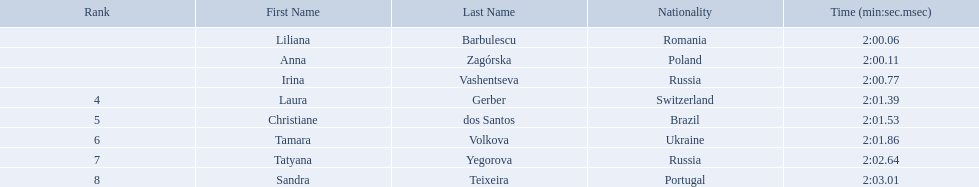What athletes are in the top five for the women's 800 metres? Liliana Barbulescu, Anna Zagórska, Irina Vashentseva, Laura Gerber, Christiane dos Santos. Which athletes are in the top 3? Liliana Barbulescu, Anna Zagórska, Irina Vashentseva. Who is the second place runner in the women's 800 metres? Anna Zagórska. What is the second place runner's time? 2:00.11. Who were the athletes? Liliana Barbulescu, 2:00.06, Anna Zagórska, 2:00.11, Irina Vashentseva, 2:00.77, Laura Gerber, 2:01.39, Christiane dos Santos, 2:01.53, Tamara Volkova, 2:01.86, Tatyana Yegorova, 2:02.64, Sandra Teixeira, 2:03.01. Who received 2nd place? Anna Zagórska, 2:00.11. What was her time? 2:00.11. Who are all of the athletes? Liliana Barbulescu, Anna Zagórska, Irina Vashentseva, Laura Gerber, Christiane dos Santos, Tamara Volkova, Tatyana Yegorova, Sandra Teixeira. What were their times in the heat? 2:00.06, 2:00.11, 2:00.77, 2:01.39, 2:01.53, 2:01.86, 2:02.64, 2:03.01. Of these, which is the top time? 2:00.06. Which athlete had this time? Liliana Barbulescu. What are the names of the competitors? Liliana Barbulescu, Anna Zagórska, Irina Vashentseva, Laura Gerber, Christiane dos Santos, Tamara Volkova, Tatyana Yegorova, Sandra Teixeira. Which finalist finished the fastest? Liliana Barbulescu. Who were the athlete were in the athletics at the 2003 summer universiade - women's 800 metres? , Liliana Barbulescu, Anna Zagórska, Irina Vashentseva, Laura Gerber, Christiane dos Santos, Tamara Volkova, Tatyana Yegorova, Sandra Teixeira. What was anna zagorska finishing time? 2:00.11. What were all the finishing times? 2:00.06, 2:00.11, 2:00.77, 2:01.39, 2:01.53, 2:01.86, 2:02.64, 2:03.01. Which of these is anna zagorska's? 2:00.11. 